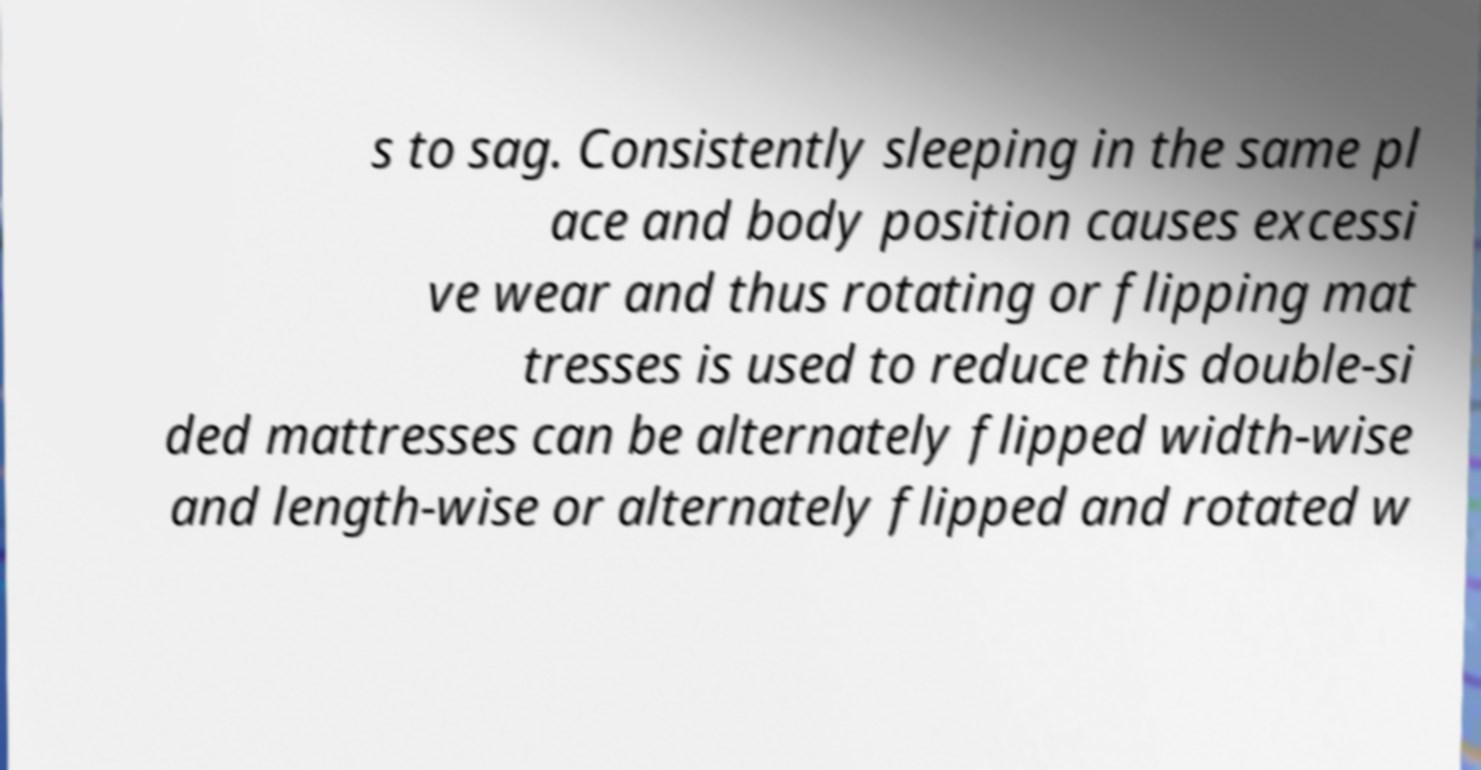For documentation purposes, I need the text within this image transcribed. Could you provide that? s to sag. Consistently sleeping in the same pl ace and body position causes excessi ve wear and thus rotating or flipping mat tresses is used to reduce this double-si ded mattresses can be alternately flipped width-wise and length-wise or alternately flipped and rotated w 